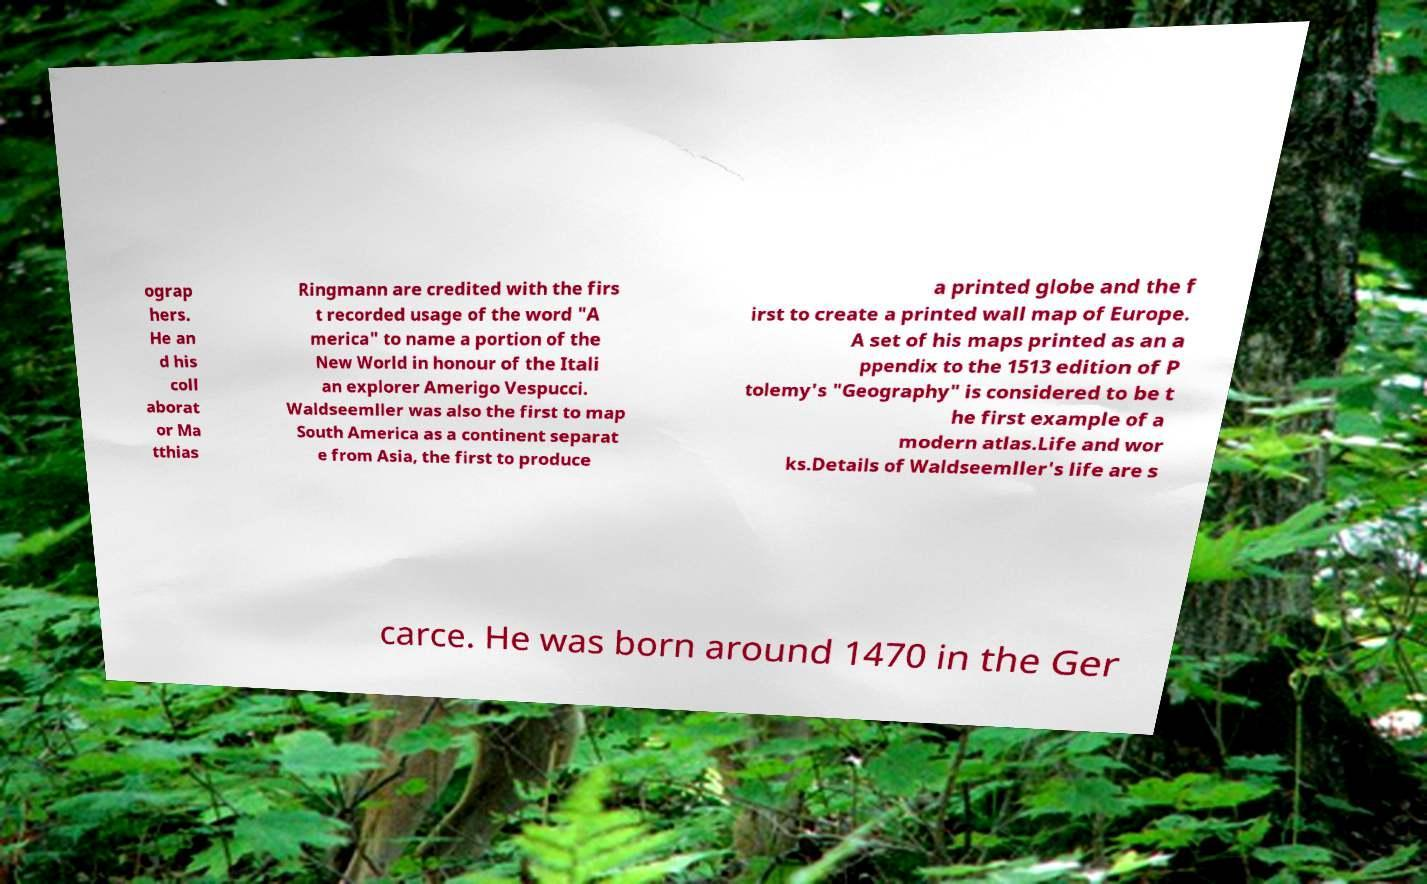Could you assist in decoding the text presented in this image and type it out clearly? ograp hers. He an d his coll aborat or Ma tthias Ringmann are credited with the firs t recorded usage of the word "A merica" to name a portion of the New World in honour of the Itali an explorer Amerigo Vespucci. Waldseemller was also the first to map South America as a continent separat e from Asia, the first to produce a printed globe and the f irst to create a printed wall map of Europe. A set of his maps printed as an a ppendix to the 1513 edition of P tolemy's "Geography" is considered to be t he first example of a modern atlas.Life and wor ks.Details of Waldseemller's life are s carce. He was born around 1470 in the Ger 